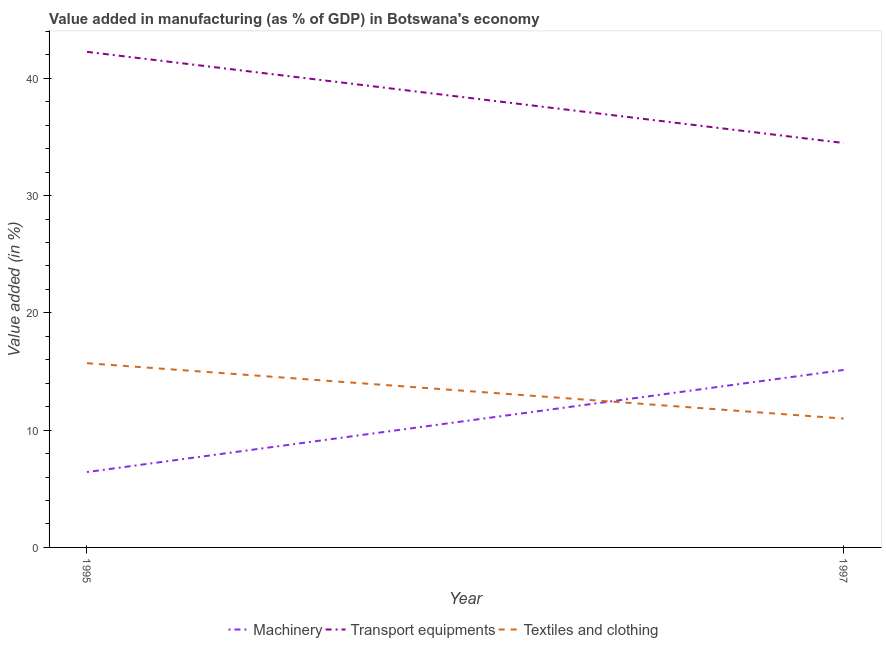Does the line corresponding to value added in manufacturing textile and clothing intersect with the line corresponding to value added in manufacturing machinery?
Keep it short and to the point. Yes. Is the number of lines equal to the number of legend labels?
Your response must be concise. Yes. What is the value added in manufacturing transport equipments in 1997?
Your answer should be compact. 34.48. Across all years, what is the maximum value added in manufacturing textile and clothing?
Offer a very short reply. 15.71. Across all years, what is the minimum value added in manufacturing machinery?
Make the answer very short. 6.43. In which year was the value added in manufacturing textile and clothing minimum?
Your response must be concise. 1997. What is the total value added in manufacturing machinery in the graph?
Your answer should be compact. 21.56. What is the difference between the value added in manufacturing textile and clothing in 1995 and that in 1997?
Offer a very short reply. 4.72. What is the difference between the value added in manufacturing textile and clothing in 1997 and the value added in manufacturing transport equipments in 1995?
Provide a short and direct response. -31.27. What is the average value added in manufacturing machinery per year?
Make the answer very short. 10.78. In the year 1997, what is the difference between the value added in manufacturing transport equipments and value added in manufacturing textile and clothing?
Your answer should be very brief. 23.5. In how many years, is the value added in manufacturing machinery greater than 26 %?
Your answer should be compact. 0. What is the ratio of the value added in manufacturing transport equipments in 1995 to that in 1997?
Give a very brief answer. 1.23. Is the value added in manufacturing machinery in 1995 less than that in 1997?
Your answer should be compact. Yes. In how many years, is the value added in manufacturing textile and clothing greater than the average value added in manufacturing textile and clothing taken over all years?
Offer a terse response. 1. Is the value added in manufacturing machinery strictly greater than the value added in manufacturing textile and clothing over the years?
Keep it short and to the point. No. What is the difference between two consecutive major ticks on the Y-axis?
Your answer should be very brief. 10. Does the graph contain grids?
Offer a terse response. No. Where does the legend appear in the graph?
Keep it short and to the point. Bottom center. How many legend labels are there?
Your answer should be compact. 3. What is the title of the graph?
Your response must be concise. Value added in manufacturing (as % of GDP) in Botswana's economy. What is the label or title of the X-axis?
Your answer should be very brief. Year. What is the label or title of the Y-axis?
Make the answer very short. Value added (in %). What is the Value added (in %) in Machinery in 1995?
Provide a short and direct response. 6.43. What is the Value added (in %) in Transport equipments in 1995?
Give a very brief answer. 42.26. What is the Value added (in %) in Textiles and clothing in 1995?
Ensure brevity in your answer.  15.71. What is the Value added (in %) in Machinery in 1997?
Make the answer very short. 15.13. What is the Value added (in %) in Transport equipments in 1997?
Keep it short and to the point. 34.48. What is the Value added (in %) in Textiles and clothing in 1997?
Your response must be concise. 10.99. Across all years, what is the maximum Value added (in %) in Machinery?
Make the answer very short. 15.13. Across all years, what is the maximum Value added (in %) in Transport equipments?
Your answer should be very brief. 42.26. Across all years, what is the maximum Value added (in %) of Textiles and clothing?
Your answer should be very brief. 15.71. Across all years, what is the minimum Value added (in %) in Machinery?
Ensure brevity in your answer.  6.43. Across all years, what is the minimum Value added (in %) of Transport equipments?
Make the answer very short. 34.48. Across all years, what is the minimum Value added (in %) in Textiles and clothing?
Your answer should be very brief. 10.99. What is the total Value added (in %) in Machinery in the graph?
Provide a short and direct response. 21.56. What is the total Value added (in %) of Transport equipments in the graph?
Keep it short and to the point. 76.74. What is the total Value added (in %) in Textiles and clothing in the graph?
Your answer should be compact. 26.69. What is the difference between the Value added (in %) of Machinery in 1995 and that in 1997?
Provide a short and direct response. -8.7. What is the difference between the Value added (in %) in Transport equipments in 1995 and that in 1997?
Provide a short and direct response. 7.77. What is the difference between the Value added (in %) in Textiles and clothing in 1995 and that in 1997?
Ensure brevity in your answer.  4.72. What is the difference between the Value added (in %) in Machinery in 1995 and the Value added (in %) in Transport equipments in 1997?
Provide a short and direct response. -28.06. What is the difference between the Value added (in %) in Machinery in 1995 and the Value added (in %) in Textiles and clothing in 1997?
Your answer should be compact. -4.56. What is the difference between the Value added (in %) of Transport equipments in 1995 and the Value added (in %) of Textiles and clothing in 1997?
Give a very brief answer. 31.27. What is the average Value added (in %) of Machinery per year?
Your answer should be very brief. 10.78. What is the average Value added (in %) in Transport equipments per year?
Your answer should be compact. 38.37. What is the average Value added (in %) of Textiles and clothing per year?
Offer a terse response. 13.35. In the year 1995, what is the difference between the Value added (in %) of Machinery and Value added (in %) of Transport equipments?
Your response must be concise. -35.83. In the year 1995, what is the difference between the Value added (in %) in Machinery and Value added (in %) in Textiles and clothing?
Your response must be concise. -9.28. In the year 1995, what is the difference between the Value added (in %) of Transport equipments and Value added (in %) of Textiles and clothing?
Your response must be concise. 26.55. In the year 1997, what is the difference between the Value added (in %) of Machinery and Value added (in %) of Transport equipments?
Your answer should be very brief. -19.35. In the year 1997, what is the difference between the Value added (in %) in Machinery and Value added (in %) in Textiles and clothing?
Provide a short and direct response. 4.14. In the year 1997, what is the difference between the Value added (in %) of Transport equipments and Value added (in %) of Textiles and clothing?
Keep it short and to the point. 23.5. What is the ratio of the Value added (in %) of Machinery in 1995 to that in 1997?
Your response must be concise. 0.42. What is the ratio of the Value added (in %) in Transport equipments in 1995 to that in 1997?
Ensure brevity in your answer.  1.23. What is the ratio of the Value added (in %) in Textiles and clothing in 1995 to that in 1997?
Your answer should be very brief. 1.43. What is the difference between the highest and the second highest Value added (in %) in Machinery?
Your answer should be very brief. 8.7. What is the difference between the highest and the second highest Value added (in %) of Transport equipments?
Provide a short and direct response. 7.77. What is the difference between the highest and the second highest Value added (in %) of Textiles and clothing?
Keep it short and to the point. 4.72. What is the difference between the highest and the lowest Value added (in %) in Machinery?
Provide a short and direct response. 8.7. What is the difference between the highest and the lowest Value added (in %) in Transport equipments?
Your answer should be compact. 7.77. What is the difference between the highest and the lowest Value added (in %) in Textiles and clothing?
Your answer should be compact. 4.72. 